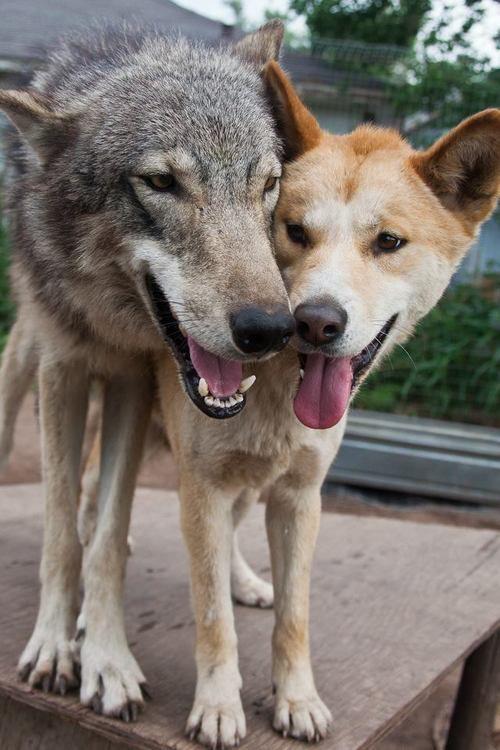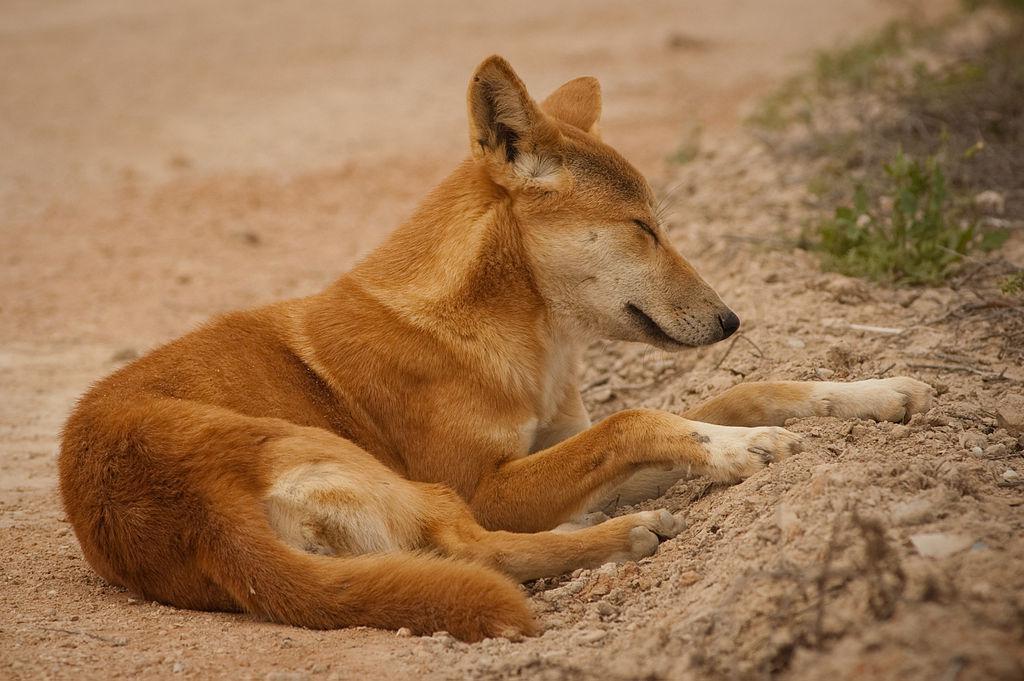The first image is the image on the left, the second image is the image on the right. Considering the images on both sides, is "The right image contains at least two wolves." valid? Answer yes or no. No. The first image is the image on the left, the second image is the image on the right. For the images displayed, is the sentence "There are no more than 3 animals in the pair of images." factually correct? Answer yes or no. Yes. 